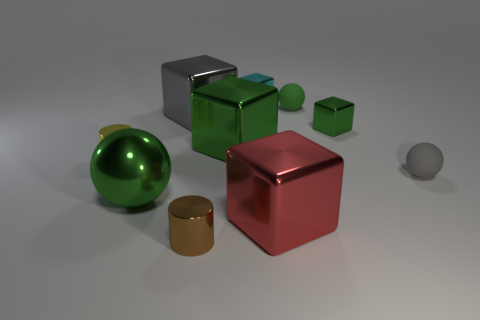Subtract all red blocks. How many blocks are left? 4 Subtract all cyan cubes. How many cubes are left? 4 Subtract all cyan blocks. Subtract all red cylinders. How many blocks are left? 4 Subtract all cylinders. How many objects are left? 8 Subtract 1 gray cubes. How many objects are left? 9 Subtract all gray rubber objects. Subtract all blue objects. How many objects are left? 9 Add 6 big gray metallic things. How many big gray metallic things are left? 7 Add 9 gray matte objects. How many gray matte objects exist? 10 